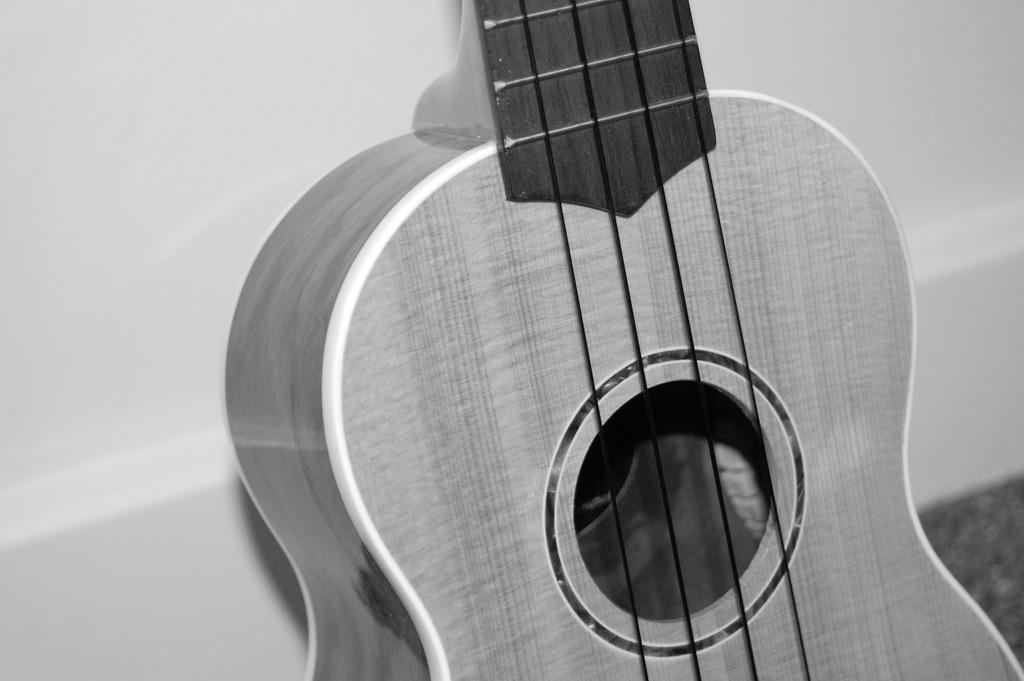What musical instrument is present in the image? There is a guitar in the image. What color is the background of the image? The background of the image is white. What type of spark can be seen coming from the guitar in the image? There is no spark visible in the image; it only shows a guitar against a white background. 